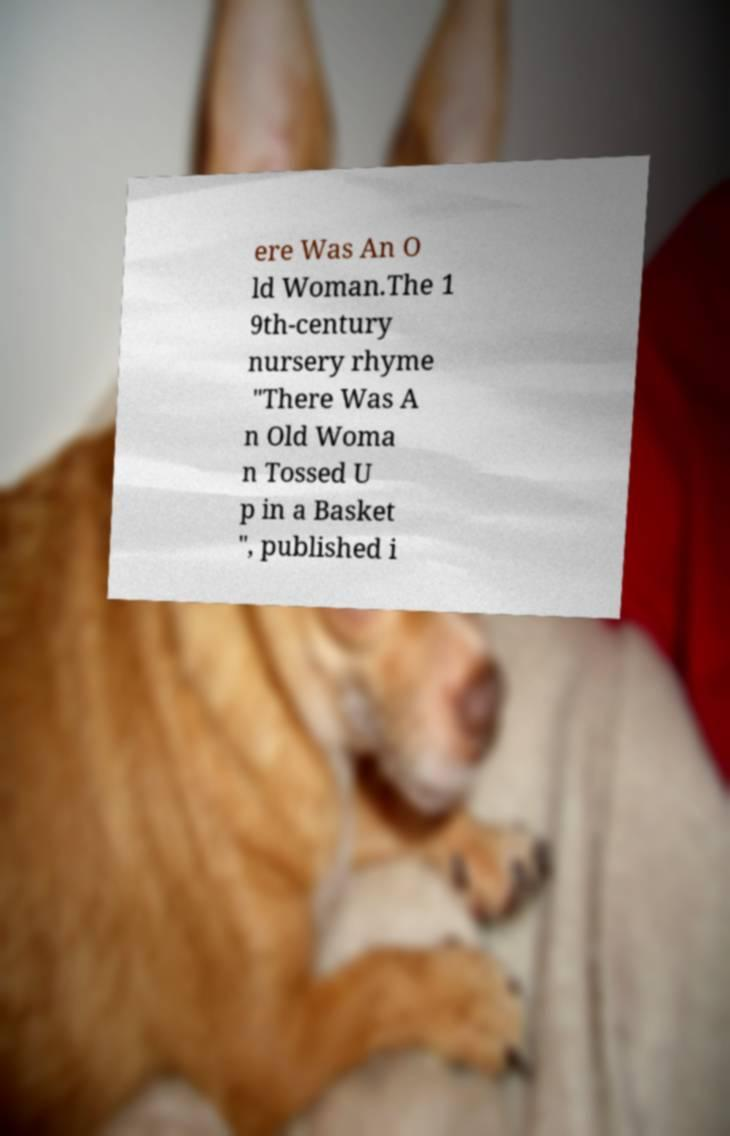Can you read and provide the text displayed in the image?This photo seems to have some interesting text. Can you extract and type it out for me? ere Was An O ld Woman.The 1 9th-century nursery rhyme "There Was A n Old Woma n Tossed U p in a Basket ", published i 